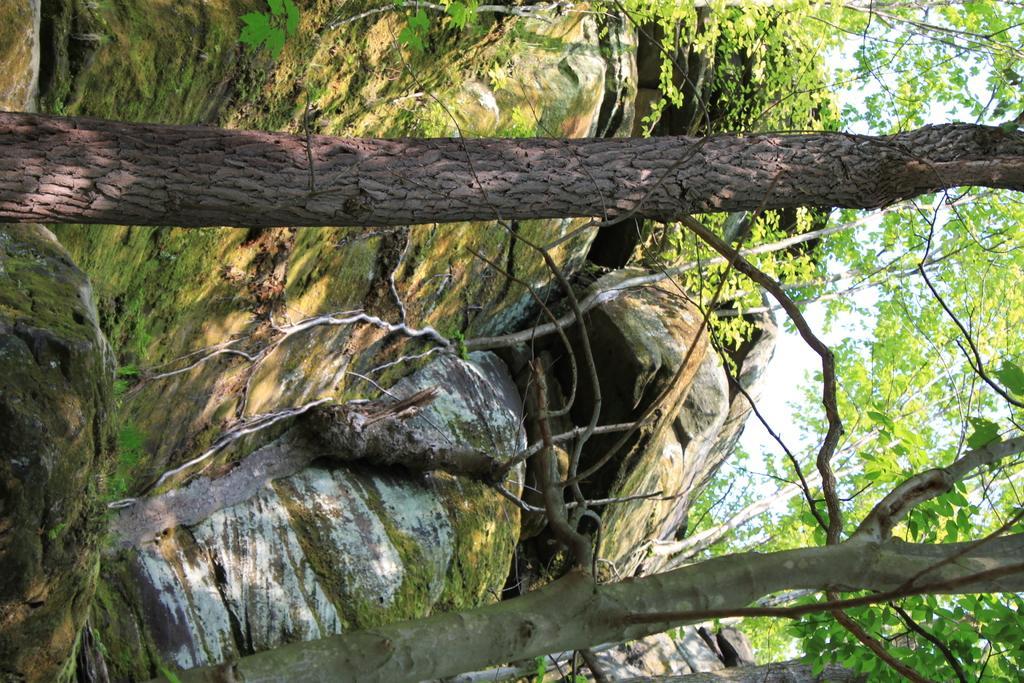Describe this image in one or two sentences. In this image we can see rocks, trees and sky. 